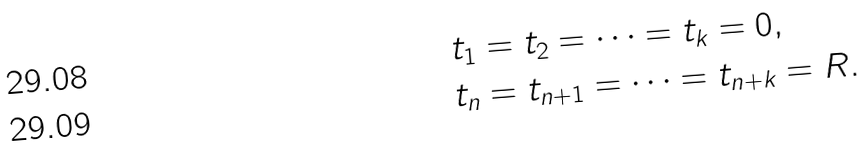<formula> <loc_0><loc_0><loc_500><loc_500>t _ { 1 } & = t _ { 2 } = \cdots = t _ { k } = 0 , \\ t _ { n } & = t _ { n + 1 } = \cdots = t _ { n + k } = R .</formula> 